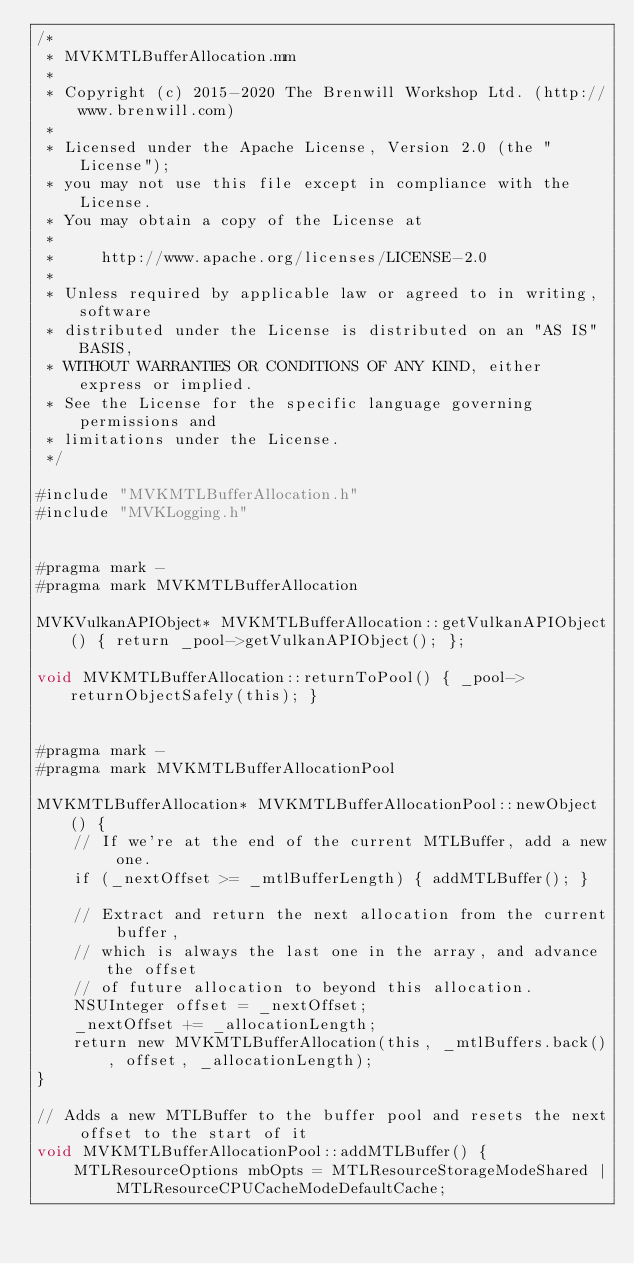<code> <loc_0><loc_0><loc_500><loc_500><_ObjectiveC_>/*
 * MVKMTLBufferAllocation.mm
 *
 * Copyright (c) 2015-2020 The Brenwill Workshop Ltd. (http://www.brenwill.com)
 *
 * Licensed under the Apache License, Version 2.0 (the "License");
 * you may not use this file except in compliance with the License.
 * You may obtain a copy of the License at
 * 
 *     http://www.apache.org/licenses/LICENSE-2.0
 * 
 * Unless required by applicable law or agreed to in writing, software
 * distributed under the License is distributed on an "AS IS" BASIS,
 * WITHOUT WARRANTIES OR CONDITIONS OF ANY KIND, either express or implied.
 * See the License for the specific language governing permissions and
 * limitations under the License.
 */

#include "MVKMTLBufferAllocation.h"
#include "MVKLogging.h"


#pragma mark -
#pragma mark MVKMTLBufferAllocation

MVKVulkanAPIObject* MVKMTLBufferAllocation::getVulkanAPIObject() { return _pool->getVulkanAPIObject(); };

void MVKMTLBufferAllocation::returnToPool() { _pool->returnObjectSafely(this); }


#pragma mark -
#pragma mark MVKMTLBufferAllocationPool

MVKMTLBufferAllocation* MVKMTLBufferAllocationPool::newObject() {
    // If we're at the end of the current MTLBuffer, add a new one.
    if (_nextOffset >= _mtlBufferLength) { addMTLBuffer(); }

    // Extract and return the next allocation from the current buffer,
    // which is always the last one in the array, and advance the offset
    // of future allocation to beyond this allocation.
    NSUInteger offset = _nextOffset;
    _nextOffset += _allocationLength;
    return new MVKMTLBufferAllocation(this, _mtlBuffers.back(), offset, _allocationLength);
}

// Adds a new MTLBuffer to the buffer pool and resets the next offset to the start of it
void MVKMTLBufferAllocationPool::addMTLBuffer() {
    MTLResourceOptions mbOpts = MTLResourceStorageModeShared | MTLResourceCPUCacheModeDefaultCache;</code> 